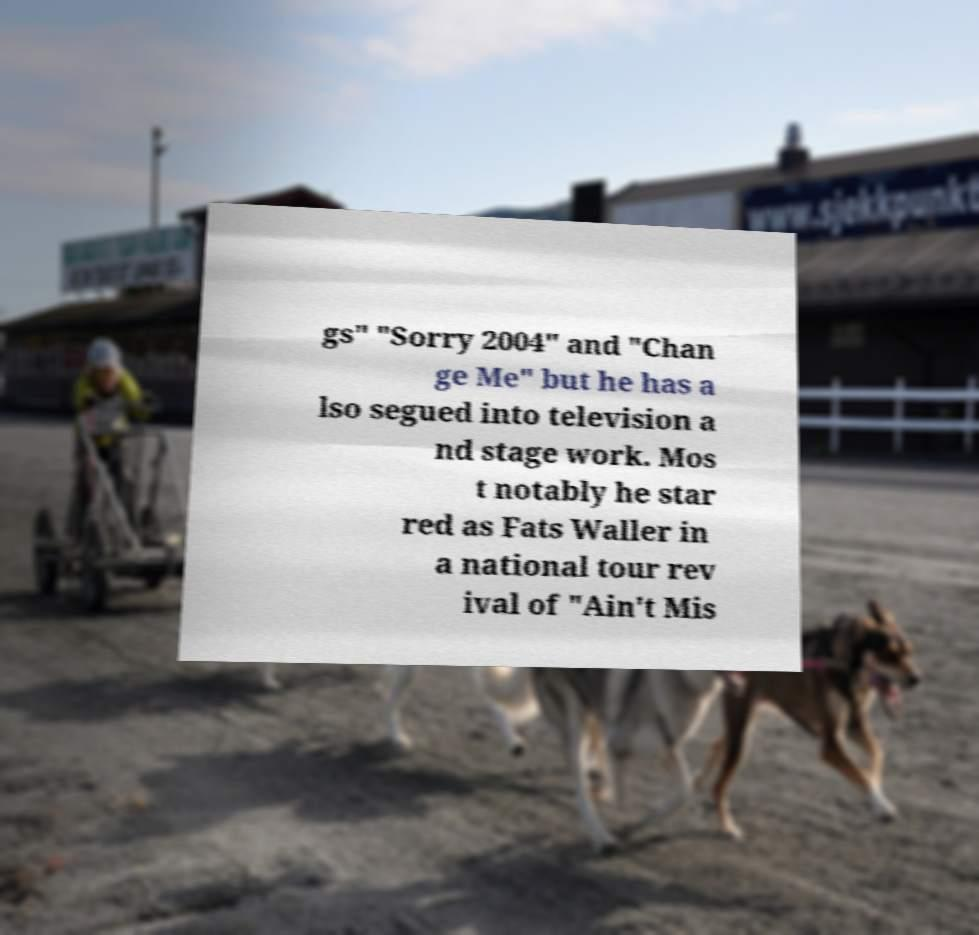Can you accurately transcribe the text from the provided image for me? gs" "Sorry 2004" and "Chan ge Me" but he has a lso segued into television a nd stage work. Mos t notably he star red as Fats Waller in a national tour rev ival of "Ain't Mis 